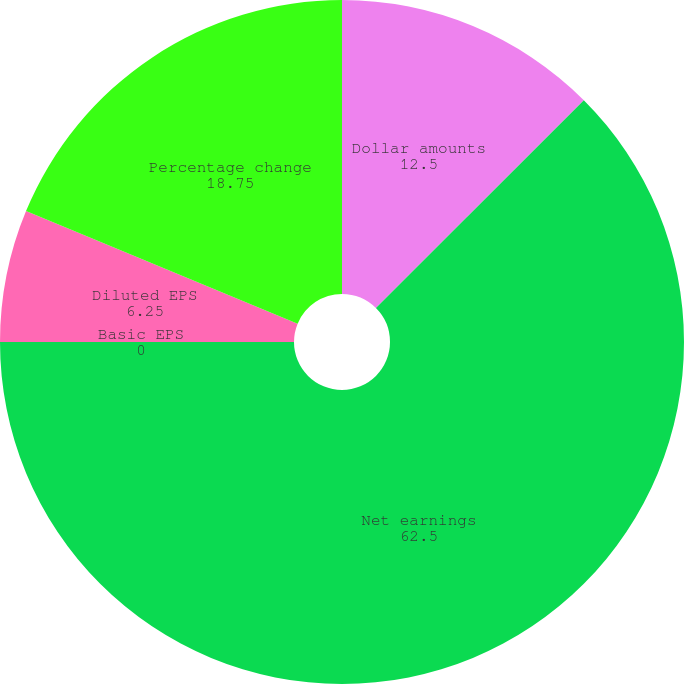Convert chart to OTSL. <chart><loc_0><loc_0><loc_500><loc_500><pie_chart><fcel>Dollar amounts<fcel>Net earnings<fcel>Basic EPS<fcel>Diluted EPS<fcel>Percentage change<nl><fcel>12.5%<fcel>62.5%<fcel>0.0%<fcel>6.25%<fcel>18.75%<nl></chart> 